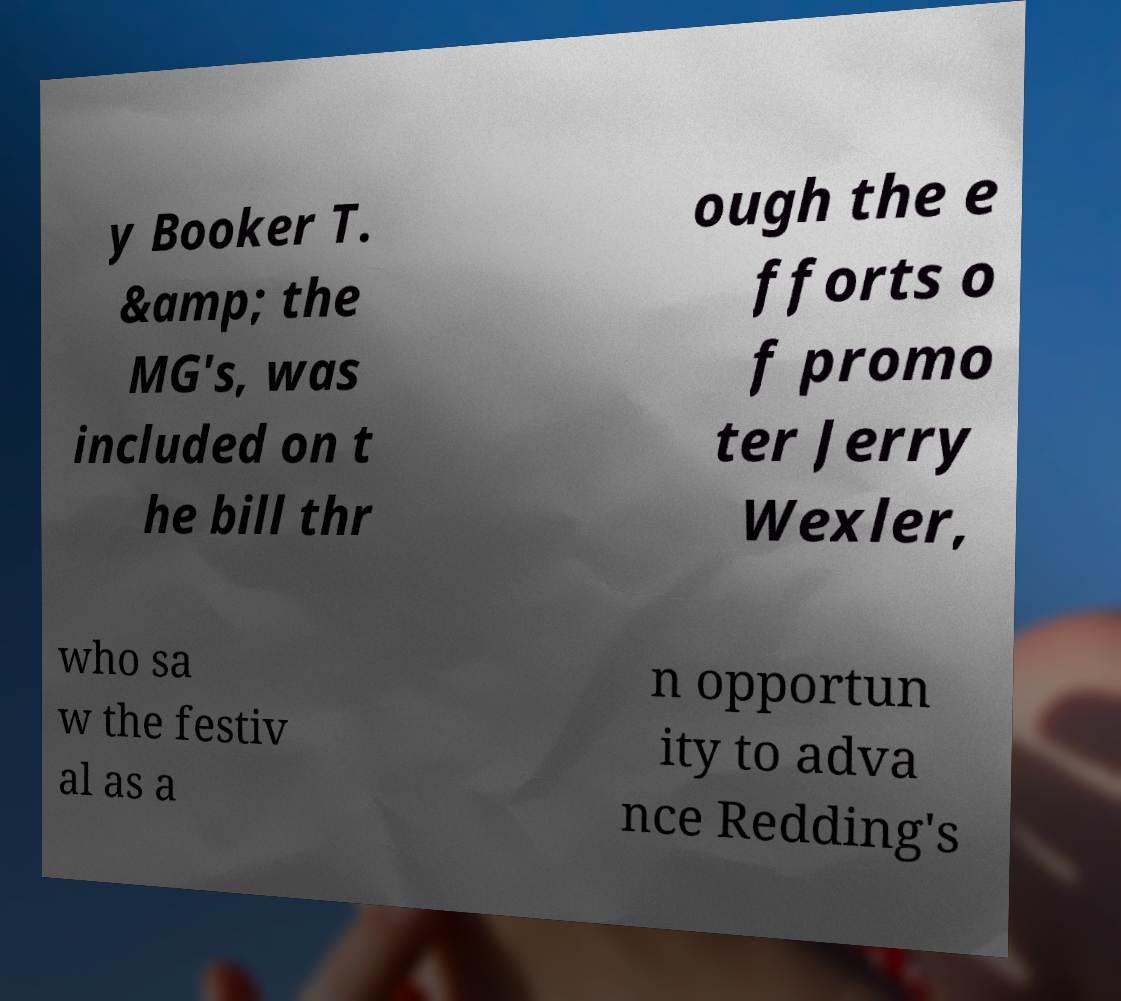Could you extract and type out the text from this image? y Booker T. &amp; the MG's, was included on t he bill thr ough the e fforts o f promo ter Jerry Wexler, who sa w the festiv al as a n opportun ity to adva nce Redding's 